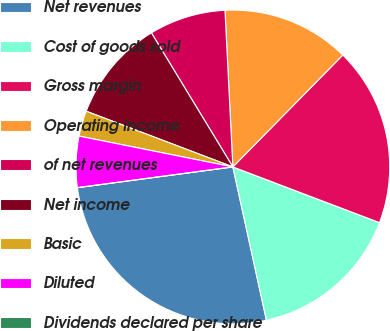<chart> <loc_0><loc_0><loc_500><loc_500><pie_chart><fcel>Net revenues<fcel>Cost of goods sold<fcel>Gross margin<fcel>Operating income<fcel>of net revenues<fcel>Net income<fcel>Basic<fcel>Diluted<fcel>Dividends declared per share<nl><fcel>26.32%<fcel>15.79%<fcel>18.42%<fcel>13.16%<fcel>7.89%<fcel>10.53%<fcel>2.63%<fcel>5.26%<fcel>0.0%<nl></chart> 